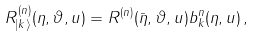<formula> <loc_0><loc_0><loc_500><loc_500>R _ { | k \rangle } ^ { ( n ) } ( \eta , \vartheta , u ) = R ^ { ( n ) } ( \bar { \eta } , \vartheta , u ) b _ { k } ^ { n } ( \eta , u ) \, ,</formula> 